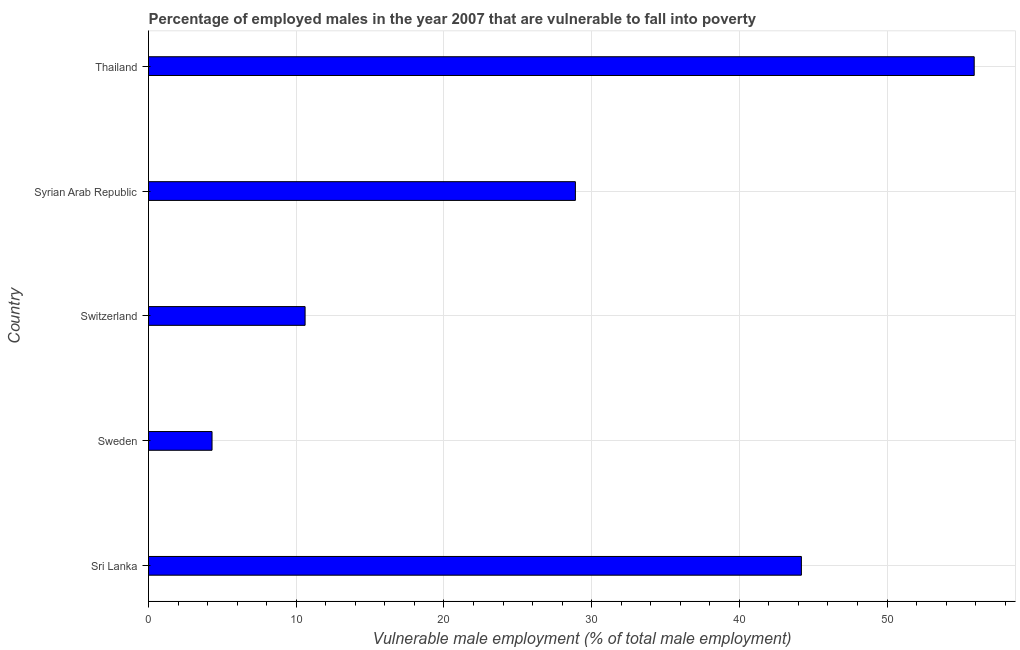Does the graph contain any zero values?
Ensure brevity in your answer.  No. What is the title of the graph?
Your answer should be very brief. Percentage of employed males in the year 2007 that are vulnerable to fall into poverty. What is the label or title of the X-axis?
Your response must be concise. Vulnerable male employment (% of total male employment). What is the label or title of the Y-axis?
Make the answer very short. Country. What is the percentage of employed males who are vulnerable to fall into poverty in Sweden?
Ensure brevity in your answer.  4.3. Across all countries, what is the maximum percentage of employed males who are vulnerable to fall into poverty?
Make the answer very short. 55.9. Across all countries, what is the minimum percentage of employed males who are vulnerable to fall into poverty?
Your response must be concise. 4.3. In which country was the percentage of employed males who are vulnerable to fall into poverty maximum?
Your answer should be very brief. Thailand. In which country was the percentage of employed males who are vulnerable to fall into poverty minimum?
Your answer should be compact. Sweden. What is the sum of the percentage of employed males who are vulnerable to fall into poverty?
Offer a very short reply. 143.9. What is the average percentage of employed males who are vulnerable to fall into poverty per country?
Your response must be concise. 28.78. What is the median percentage of employed males who are vulnerable to fall into poverty?
Provide a succinct answer. 28.9. In how many countries, is the percentage of employed males who are vulnerable to fall into poverty greater than 28 %?
Make the answer very short. 3. What is the ratio of the percentage of employed males who are vulnerable to fall into poverty in Switzerland to that in Syrian Arab Republic?
Keep it short and to the point. 0.37. What is the difference between the highest and the lowest percentage of employed males who are vulnerable to fall into poverty?
Your answer should be very brief. 51.6. How many countries are there in the graph?
Your answer should be very brief. 5. What is the Vulnerable male employment (% of total male employment) in Sri Lanka?
Provide a short and direct response. 44.2. What is the Vulnerable male employment (% of total male employment) of Sweden?
Provide a succinct answer. 4.3. What is the Vulnerable male employment (% of total male employment) of Switzerland?
Provide a succinct answer. 10.6. What is the Vulnerable male employment (% of total male employment) in Syrian Arab Republic?
Your answer should be compact. 28.9. What is the Vulnerable male employment (% of total male employment) of Thailand?
Keep it short and to the point. 55.9. What is the difference between the Vulnerable male employment (% of total male employment) in Sri Lanka and Sweden?
Provide a short and direct response. 39.9. What is the difference between the Vulnerable male employment (% of total male employment) in Sri Lanka and Switzerland?
Provide a succinct answer. 33.6. What is the difference between the Vulnerable male employment (% of total male employment) in Sri Lanka and Thailand?
Ensure brevity in your answer.  -11.7. What is the difference between the Vulnerable male employment (% of total male employment) in Sweden and Syrian Arab Republic?
Offer a terse response. -24.6. What is the difference between the Vulnerable male employment (% of total male employment) in Sweden and Thailand?
Your answer should be very brief. -51.6. What is the difference between the Vulnerable male employment (% of total male employment) in Switzerland and Syrian Arab Republic?
Ensure brevity in your answer.  -18.3. What is the difference between the Vulnerable male employment (% of total male employment) in Switzerland and Thailand?
Offer a very short reply. -45.3. What is the difference between the Vulnerable male employment (% of total male employment) in Syrian Arab Republic and Thailand?
Make the answer very short. -27. What is the ratio of the Vulnerable male employment (% of total male employment) in Sri Lanka to that in Sweden?
Provide a short and direct response. 10.28. What is the ratio of the Vulnerable male employment (% of total male employment) in Sri Lanka to that in Switzerland?
Ensure brevity in your answer.  4.17. What is the ratio of the Vulnerable male employment (% of total male employment) in Sri Lanka to that in Syrian Arab Republic?
Your response must be concise. 1.53. What is the ratio of the Vulnerable male employment (% of total male employment) in Sri Lanka to that in Thailand?
Give a very brief answer. 0.79. What is the ratio of the Vulnerable male employment (% of total male employment) in Sweden to that in Switzerland?
Your response must be concise. 0.41. What is the ratio of the Vulnerable male employment (% of total male employment) in Sweden to that in Syrian Arab Republic?
Your response must be concise. 0.15. What is the ratio of the Vulnerable male employment (% of total male employment) in Sweden to that in Thailand?
Offer a terse response. 0.08. What is the ratio of the Vulnerable male employment (% of total male employment) in Switzerland to that in Syrian Arab Republic?
Offer a very short reply. 0.37. What is the ratio of the Vulnerable male employment (% of total male employment) in Switzerland to that in Thailand?
Make the answer very short. 0.19. What is the ratio of the Vulnerable male employment (% of total male employment) in Syrian Arab Republic to that in Thailand?
Your response must be concise. 0.52. 